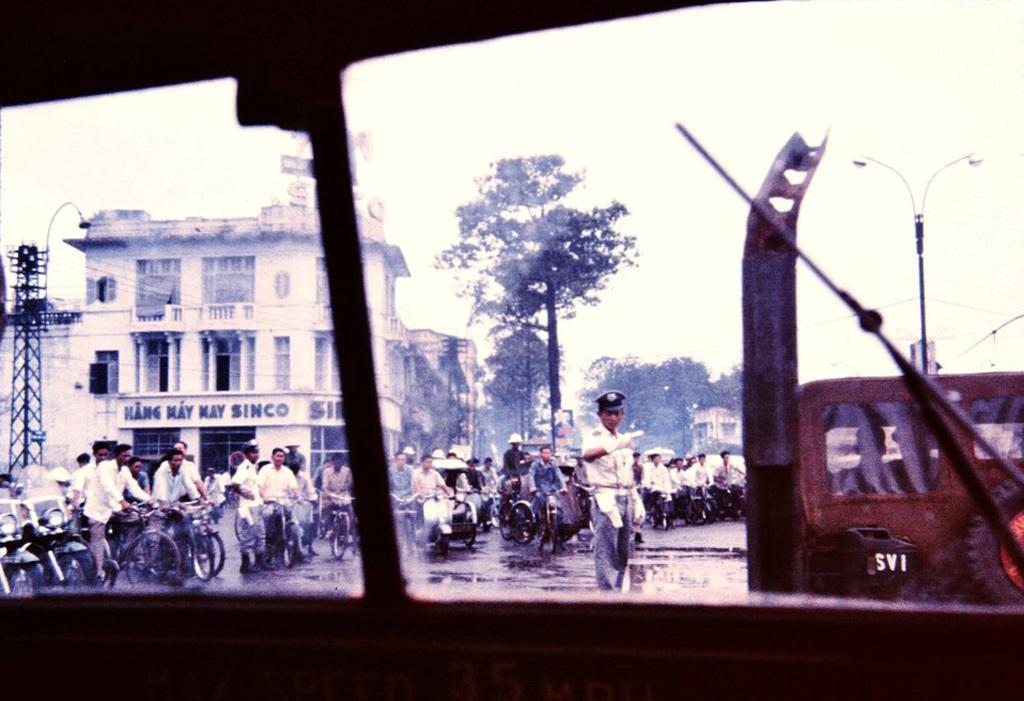How many people are present in the image? There are people in the image, but the exact number is not specified. What are some people doing in the image? Some people are sitting on vehicles in the image. What type of natural elements can be seen in the image? There are trees in the image. What type of man-made structures can be seen in the image? There are buildings in the image. What type of vertical structures can be seen in the image? There are poles in the image. What type of artificial light sources can be seen in the image? There are lights in the image. What is visible in the background of the image? The sky is visible in the background of the image. What type of chin can be seen on the tent in the image? There is no tent present in the image, so there is no chin to be seen on it. 